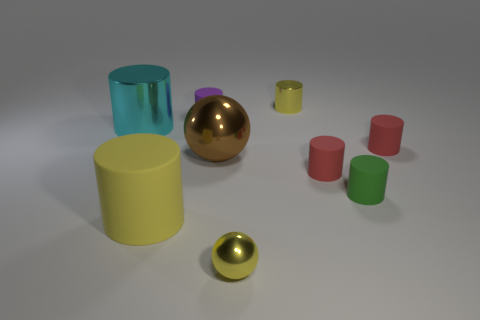What material is the tiny ball that is the same color as the big matte cylinder?
Your response must be concise. Metal. How many tiny objects are both to the right of the small purple cylinder and behind the big matte cylinder?
Ensure brevity in your answer.  4. The tiny thing to the left of the tiny yellow metallic object that is in front of the big cyan metal thing is made of what material?
Keep it short and to the point. Rubber. Is there a tiny red cylinder that has the same material as the large brown object?
Give a very brief answer. No. There is a yellow object that is the same size as the brown ball; what is its material?
Provide a short and direct response. Rubber. There is a yellow cylinder that is behind the cyan thing that is behind the large shiny thing in front of the cyan metal object; what size is it?
Make the answer very short. Small. There is a big cylinder behind the big rubber thing; is there a big yellow thing behind it?
Offer a terse response. No. There is a yellow matte thing; is its shape the same as the yellow object behind the large brown thing?
Provide a short and direct response. Yes. There is a small cylinder to the left of the tiny metallic ball; what color is it?
Provide a short and direct response. Purple. What size is the yellow metallic object that is in front of the large cylinder behind the large brown shiny sphere?
Make the answer very short. Small. 